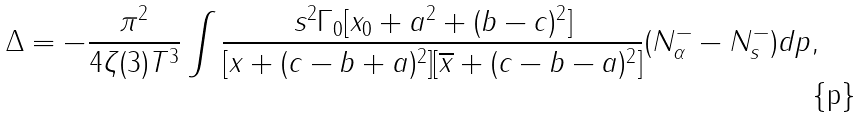<formula> <loc_0><loc_0><loc_500><loc_500>\Delta = - \frac { \pi ^ { 2 } } { 4 \zeta ( 3 ) T ^ { 3 } } \int \frac { s ^ { 2 } \Gamma _ { 0 } [ x _ { 0 } + a ^ { 2 } + ( b - c ) ^ { 2 } ] } { [ x + ( c - b + a ) ^ { 2 } ] [ \overline { x } + ( c - b - a ) ^ { 2 } ] } ( N ^ { - } _ { \alpha } - N ^ { - } _ { s } ) d p ,</formula> 